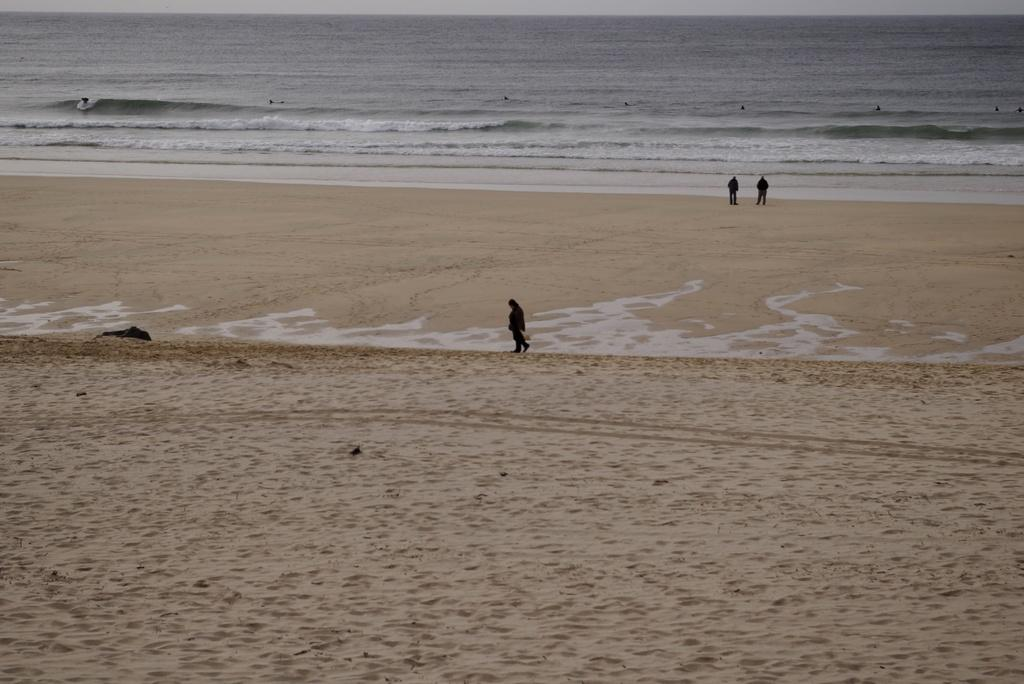What is the black object in the image? The black object in the image is not specified, but it could be an umbrella, a bag, or another item. What type of terrain is visible in the image? There is sand and water visible in the image, suggesting a beach or a shoreline. Can you describe the people in the image? There are people standing in the image, but their specific actions or appearances are not mentioned in the facts. What type of worm can be seen crawling on the receipt in the image? There is no worm or receipt present in the image; it features a black object, sand, water, and people. How many legs does the leg have in the image? The question is unclear and seems to be a trick question, as it refers to a "leg" without specifying what it is. However, the image does not show any legs or body parts that could be counted. 